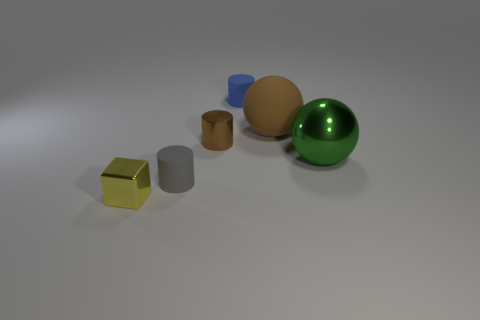Add 1 big brown matte objects. How many objects exist? 7 Subtract all spheres. How many objects are left? 4 Add 1 small blue matte things. How many small blue matte things are left? 2 Add 1 large blue things. How many large blue things exist? 1 Subtract 1 yellow blocks. How many objects are left? 5 Subtract all tiny purple shiny spheres. Subtract all tiny brown metallic things. How many objects are left? 5 